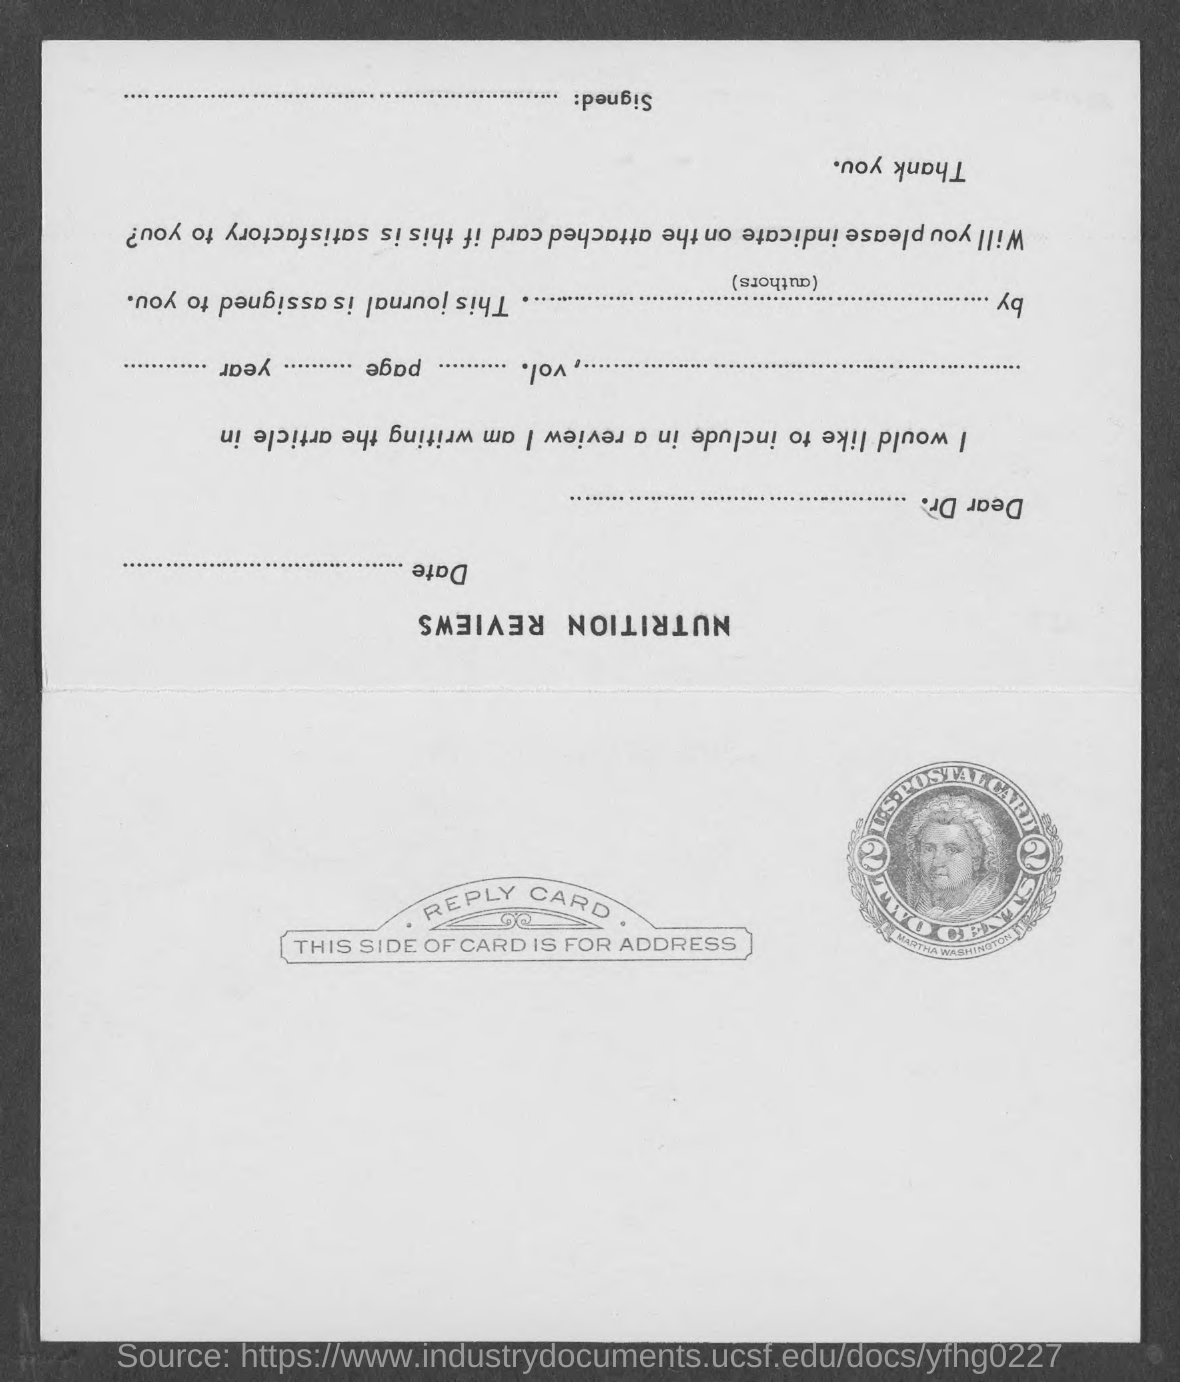To which country does this post card belong?
Give a very brief answer. U.S. What is name of the women in the postal stamp?
Keep it short and to the point. Martha Washington. 